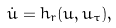Convert formula to latex. <formula><loc_0><loc_0><loc_500><loc_500>\dot { u } = h _ { r } ( u , u _ { \tau } ) ,</formula> 